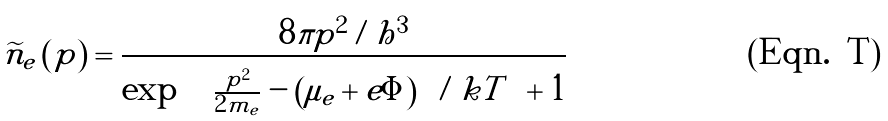<formula> <loc_0><loc_0><loc_500><loc_500>\widetilde { n } _ { e } \left ( p \right ) = \frac { 8 \pi p ^ { 2 } / h ^ { 3 } } { \exp \left \{ \left [ \frac { p ^ { 2 } } { 2 m _ { e } } - \left ( \mu _ { e } + e \Phi \right ) \right ] / k T \right \} + 1 }</formula> 